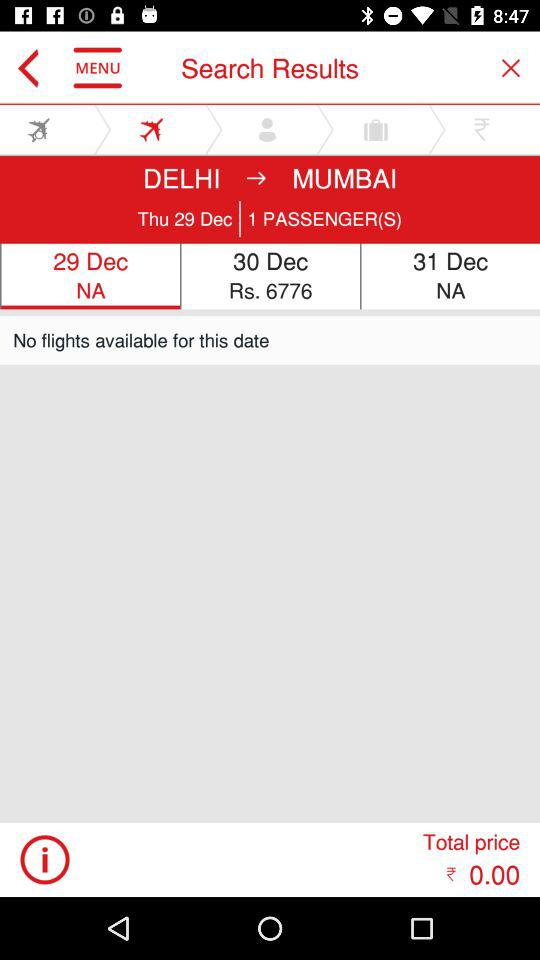What is the price of a flight on 30th December? The price of a flight on 30th December is Rs. 6776. 